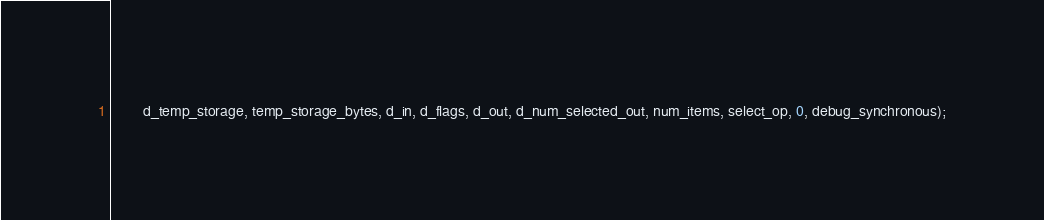Convert code to text. <code><loc_0><loc_0><loc_500><loc_500><_Cuda_>        d_temp_storage, temp_storage_bytes, d_in, d_flags, d_out, d_num_selected_out, num_items, select_op, 0, debug_synchronous);</code> 